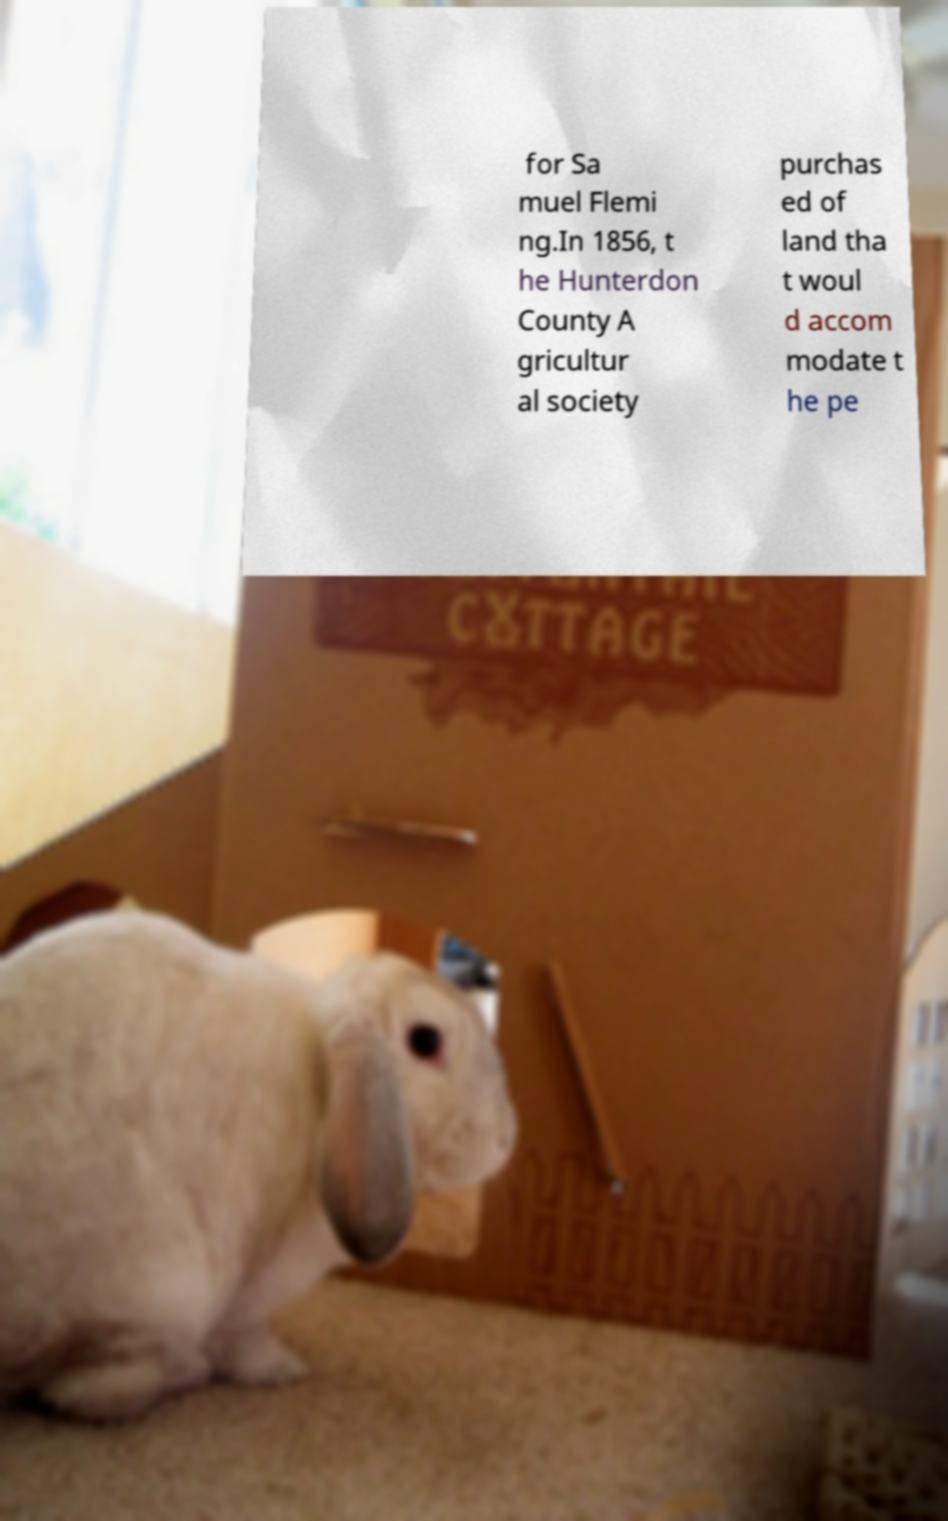Can you accurately transcribe the text from the provided image for me? for Sa muel Flemi ng.In 1856, t he Hunterdon County A gricultur al society purchas ed of land tha t woul d accom modate t he pe 